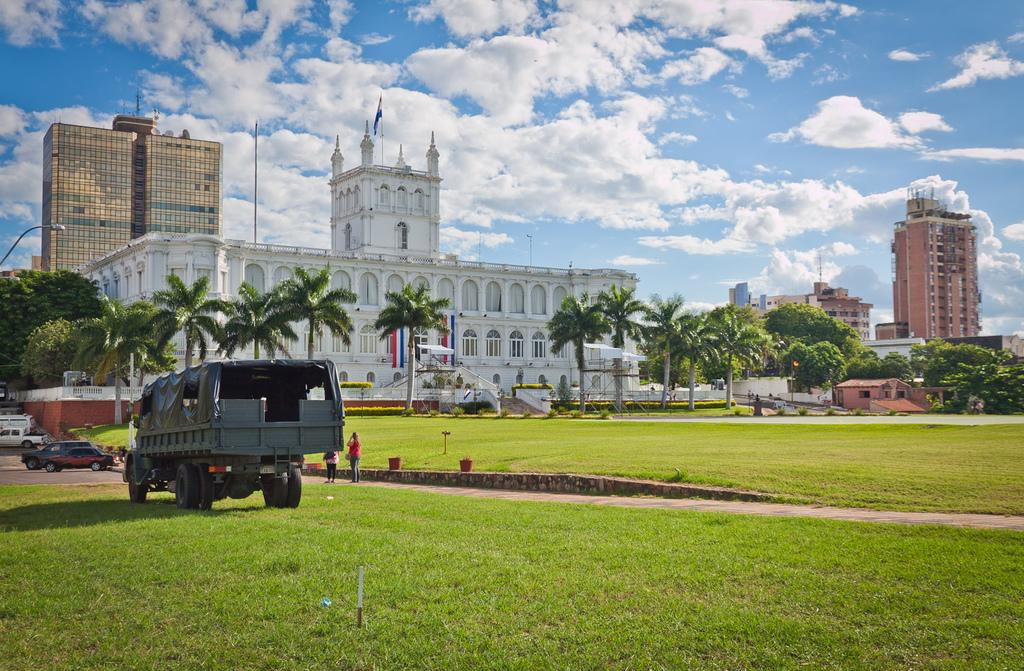What type of structures can be seen in the image? There are buildings in the image. What can be seen on the left side of the image? Vehicles are visible on the left side of the image. What type of vegetation is at the bottom of the image? There is grass at the bottom of the image. Can you describe the people in the image? People are present in the image. What is visible in the background of the image? There are trees and the sky in the background of the image. What type of pest is causing trouble for the people in the image? There is no indication of any pest causing trouble in the image. Can you tell me which doctor is treating the people in the image? There is no doctor present in the image, nor is there any indication that the people require medical attention. 